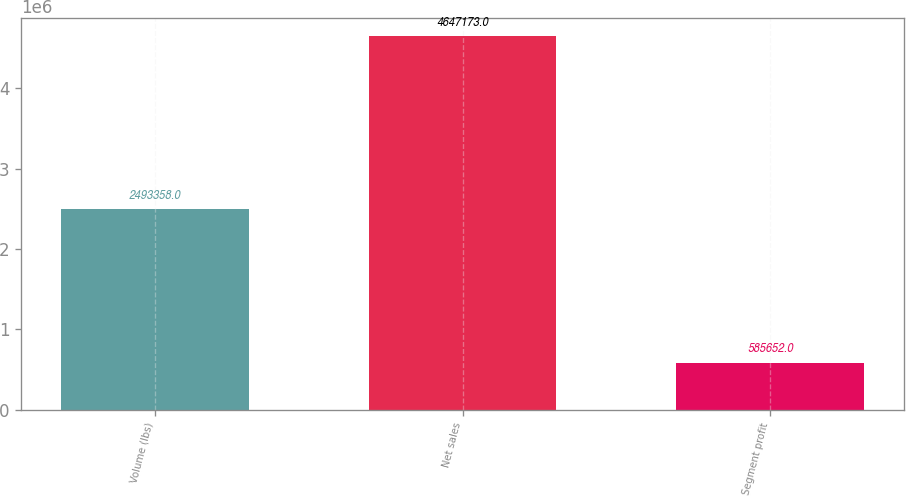<chart> <loc_0><loc_0><loc_500><loc_500><bar_chart><fcel>Volume (lbs)<fcel>Net sales<fcel>Segment profit<nl><fcel>2.49336e+06<fcel>4.64717e+06<fcel>585652<nl></chart> 